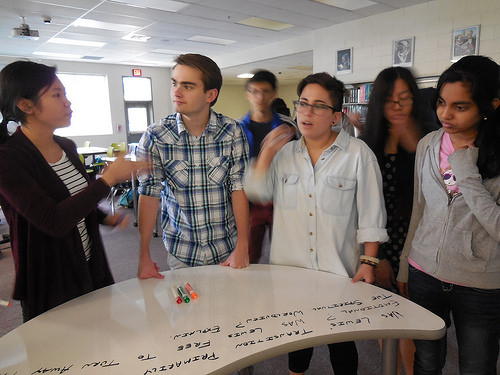<image>
Can you confirm if the man is behind the woman? Yes. From this viewpoint, the man is positioned behind the woman, with the woman partially or fully occluding the man. 